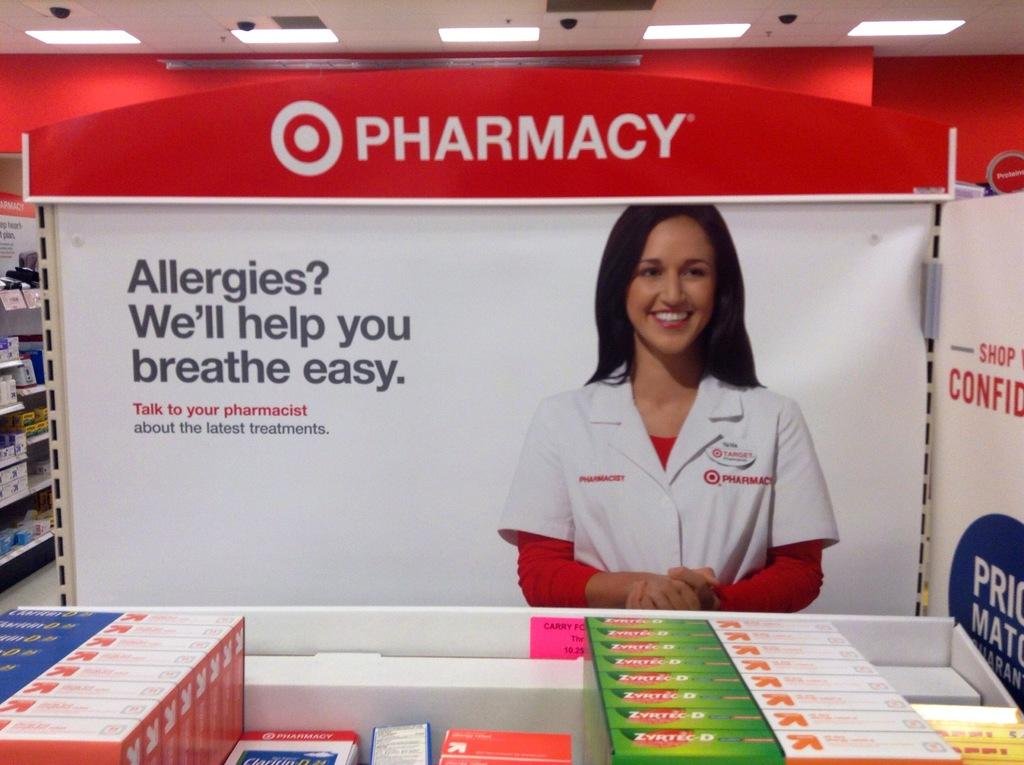<image>
Give a short and clear explanation of the subsequent image. If you have allergies, the Target pharmacy can help you breathe easy. 